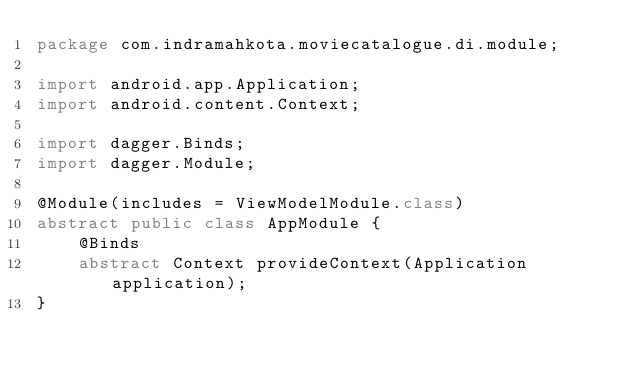Convert code to text. <code><loc_0><loc_0><loc_500><loc_500><_Java_>package com.indramahkota.moviecatalogue.di.module;

import android.app.Application;
import android.content.Context;

import dagger.Binds;
import dagger.Module;

@Module(includes = ViewModelModule.class)
abstract public class AppModule {
    @Binds
    abstract Context provideContext(Application application);
}
</code> 